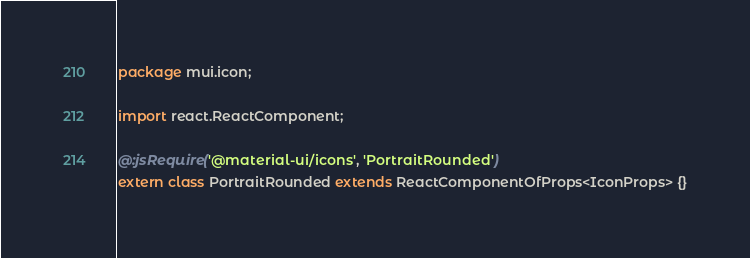<code> <loc_0><loc_0><loc_500><loc_500><_Haxe_>package mui.icon;

import react.ReactComponent;

@:jsRequire('@material-ui/icons', 'PortraitRounded')
extern class PortraitRounded extends ReactComponentOfProps<IconProps> {}
</code> 